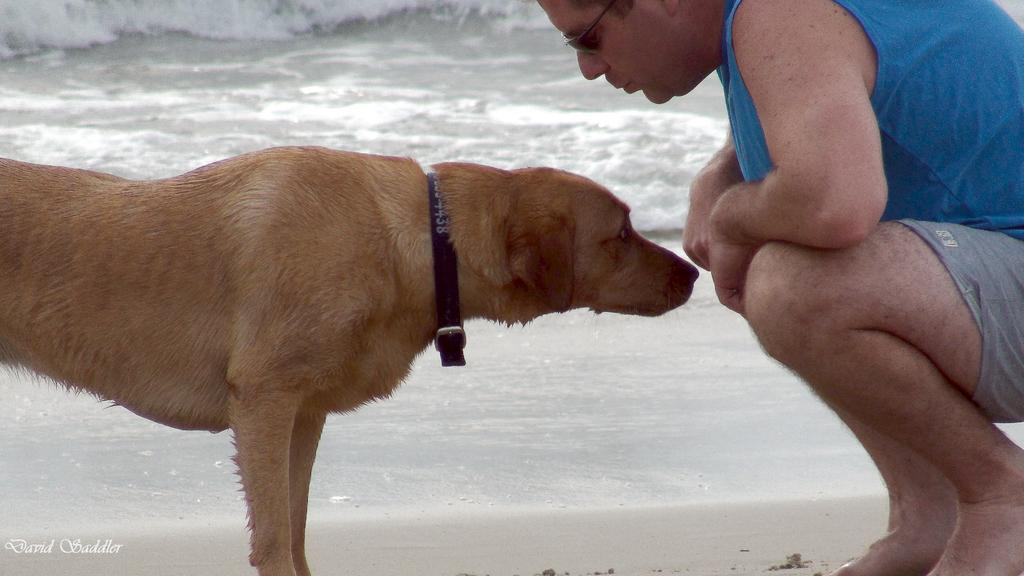Who or what is the main subject in the image? There is a person in the image. What is the person doing or interacting with in the image? The person is in front of a dog. Can you describe the environment or setting in the image? There is water visible in the image. What type of cakes can be seen floating in the water in the image? There are no cakes visible in the image; it features a person in front of a dog near water. What scent is emanating from the dog in the image? The image does not provide information about the scent of the dog, as it is a visual medium. 